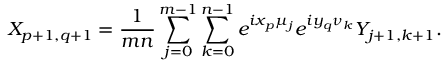<formula> <loc_0><loc_0><loc_500><loc_500>X _ { p + 1 , q + 1 } = \frac { 1 } { m n } \sum _ { j = 0 } ^ { m - 1 } \sum _ { k = 0 } ^ { n - 1 } e ^ { i x _ { p } \mu _ { j } } e ^ { i y _ { q } \nu _ { k } } Y _ { j + 1 , k + 1 } .</formula> 